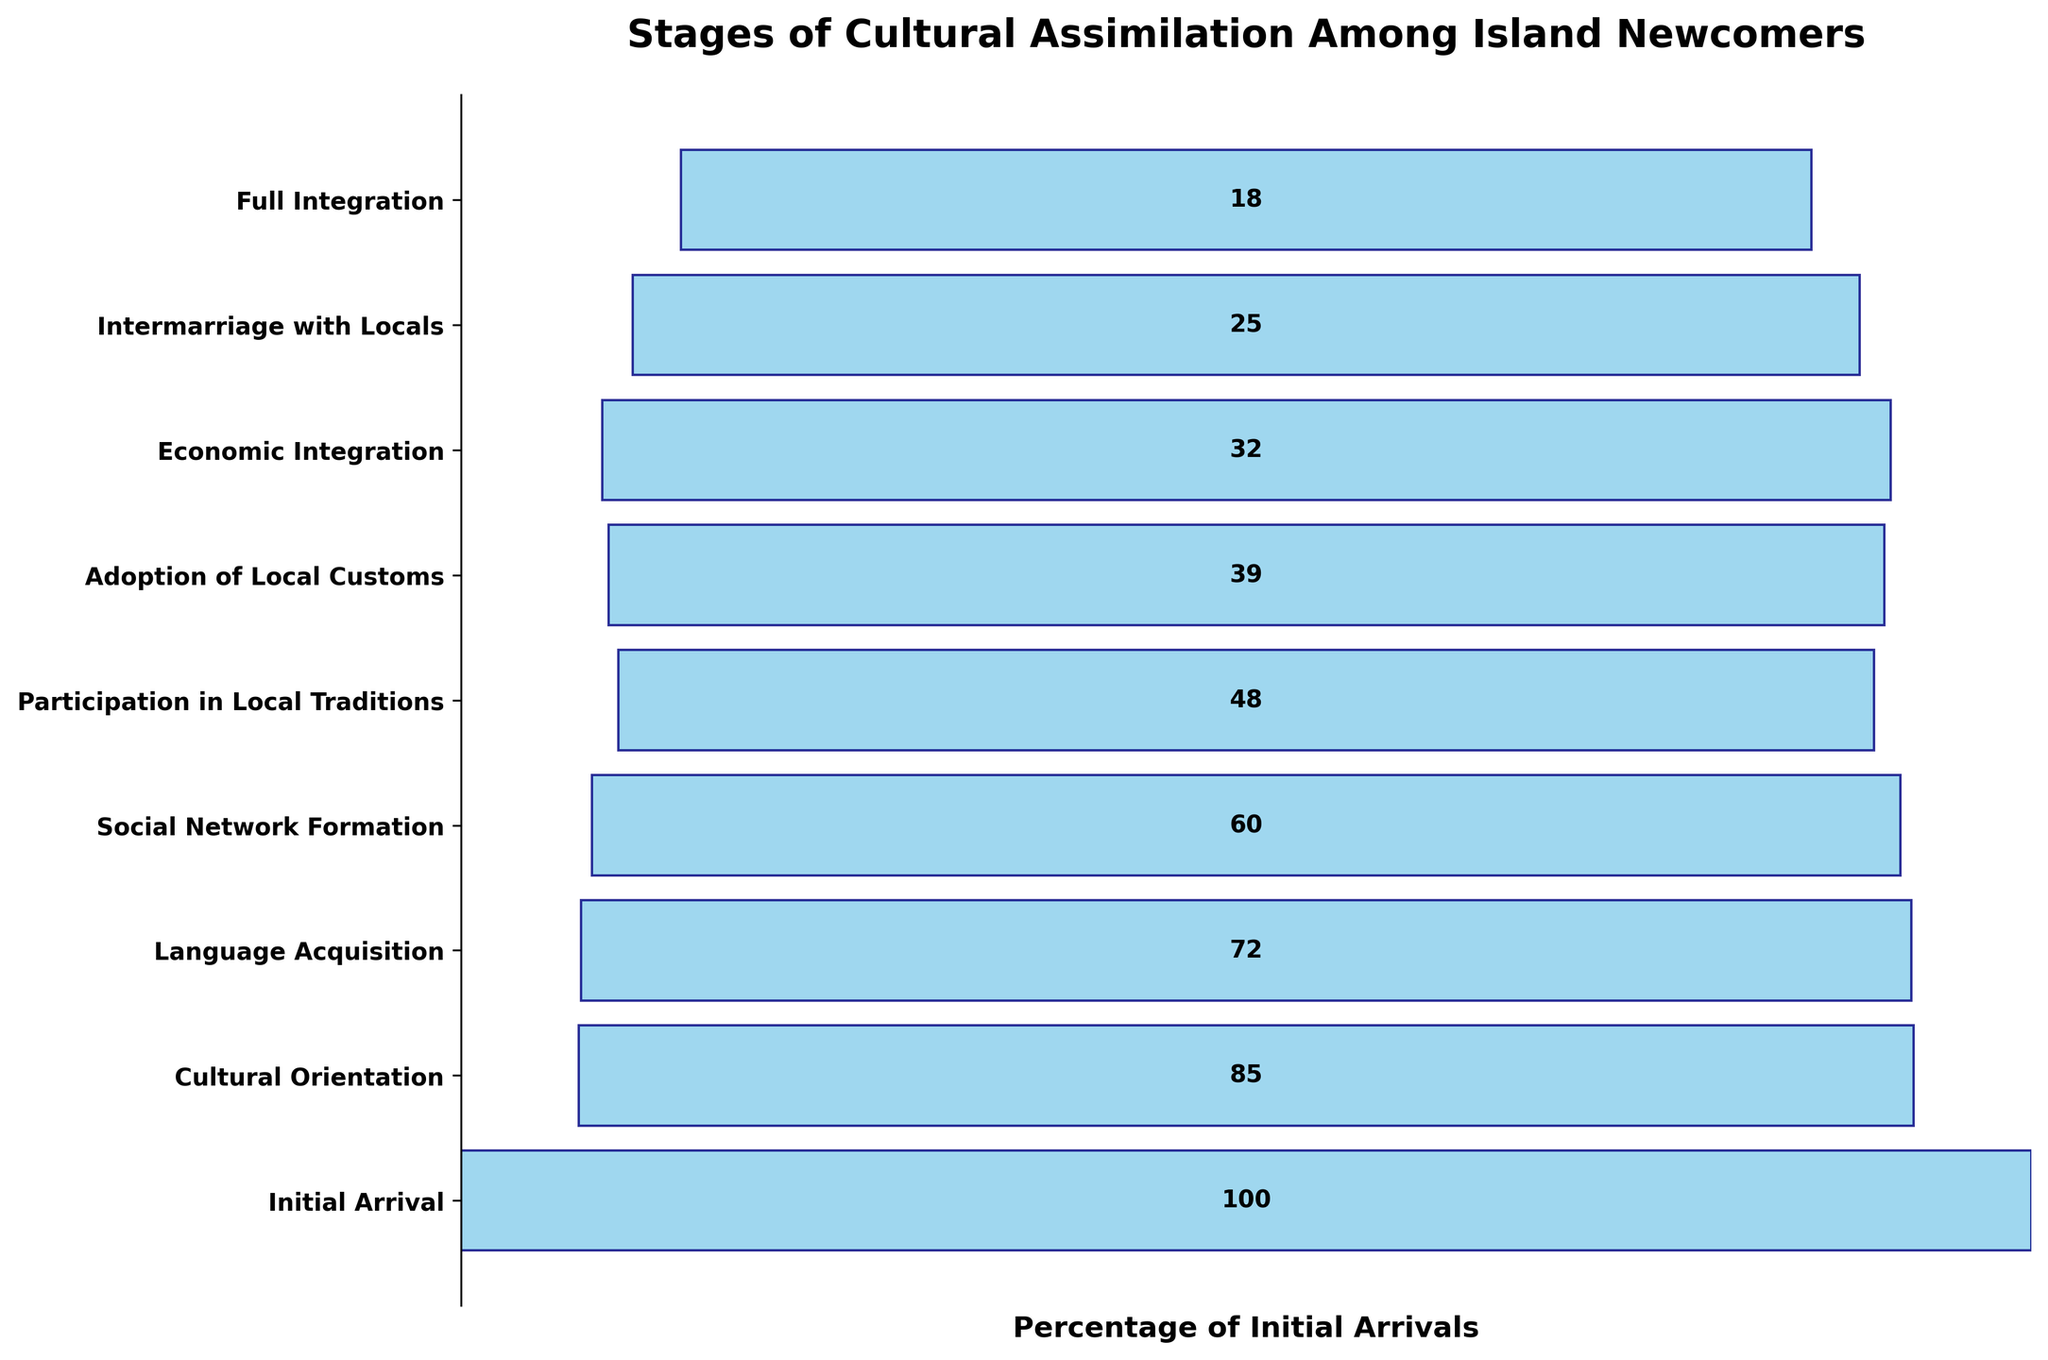What is the title of this chart? The title is located at the top of the chart and is generally the most noticeable text.
Answer: Stages of Cultural Assimilation Among Island Newcomers How many stages are represented in the chart? We can count the number of horizontal bars and corresponding labels on the y-axis to determine the number of stages.
Answer: 8 Which stage has the largest number of newcomers? The stage with the largest number of newcomers is represented by the widest bar or the highest value on the y-axis.
Answer: Initial Arrival Compare the number of newcomers at the stages of 'Language Acquisition' and 'Economic Integration.' Which stage has more newcomers? By looking at the lengths of the respective bars or comparing the numbers listed inside the bars, we can see which stage has more newcomers.
Answer: Language Acquisition What is the percentage decrease in newcomers from 'Initial Arrival' to 'Cultural Orientation'? Calculate the percentage decrease using the formula: ((100 - 85) / 100) * 100.
Answer: 15% How many newcomers reach the stage of 'Full Integration'? The number of newcomers at each stage is labeled on the bar within the chart. Look for the label corresponding to the 'Full Integration' stage.
Answer: 18 What is the difference in the number of newcomers between 'Participation in Local Traditions' and 'Adoption of Local Customs'? Subtract the number of newcomers at 'Adoption of Local Customs' from those at 'Participation in Local Traditions': 48 - 39.
Answer: 9 Which stage shows the largest drop in the number of newcomers from the previous stage? By comparing the total number of newcomers between consecutive stages, identify the largest decrease.
Answer: Language Acquisition to Social Network Formation What's the cumulative number of newcomers from 'Economic Integration' to 'Full Integration'? Sum the numbers of newcomers at 'Economic Integration,' 'Intermarriage with Locals,' and 'Full Integration': 32 + 25 + 18.
Answer: 75 What percentage of the newcomers at 'Initial Arrival' reach the 'Intermarriage with Locals' stage? Calculate the percentage using the formula: (25 / 100) * 100.
Answer: 25% 